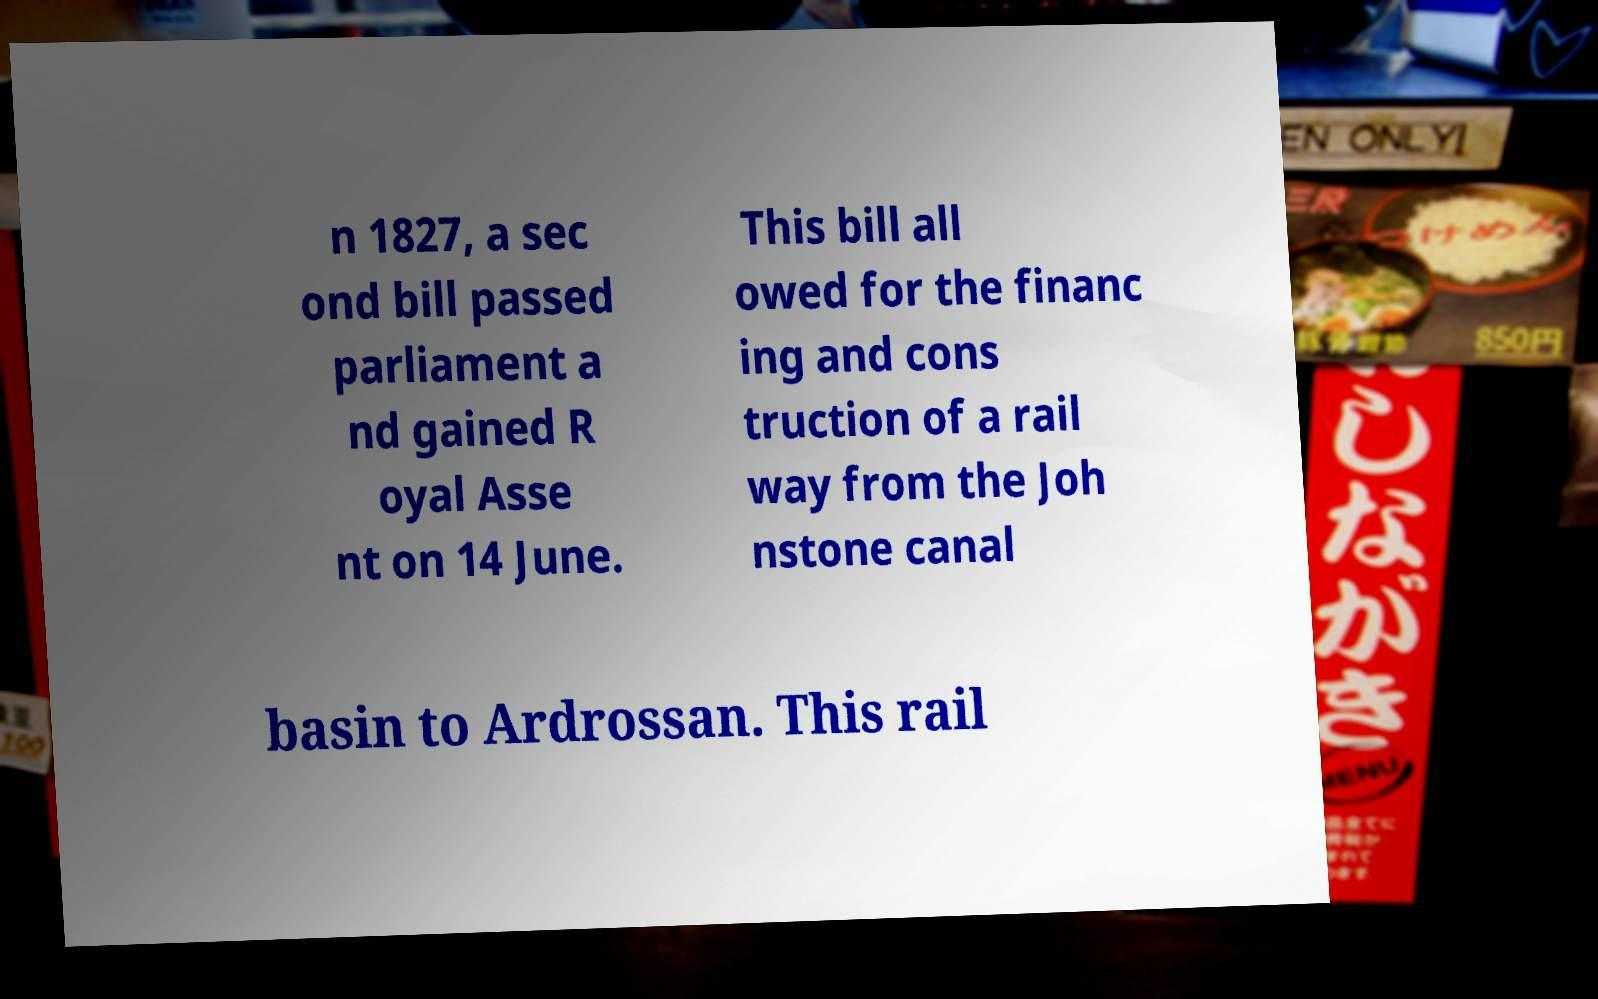For documentation purposes, I need the text within this image transcribed. Could you provide that? n 1827, a sec ond bill passed parliament a nd gained R oyal Asse nt on 14 June. This bill all owed for the financ ing and cons truction of a rail way from the Joh nstone canal basin to Ardrossan. This rail 